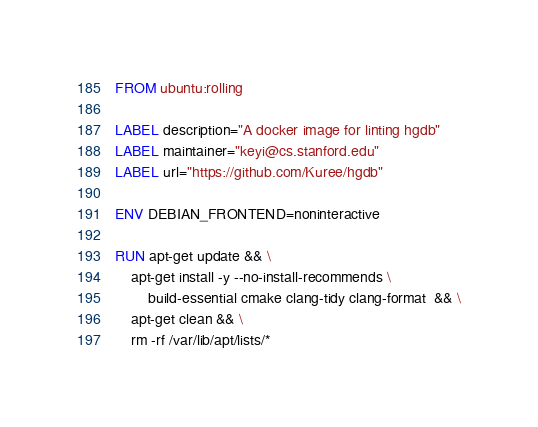Convert code to text. <code><loc_0><loc_0><loc_500><loc_500><_Dockerfile_>FROM ubuntu:rolling

LABEL description="A docker image for linting hgdb"
LABEL maintainer="keyi@cs.stanford.edu"
LABEL url="https://github.com/Kuree/hgdb"

ENV DEBIAN_FRONTEND=noninteractive

RUN apt-get update && \
    apt-get install -y --no-install-recommends \
        build-essential cmake clang-tidy clang-format  && \
    apt-get clean && \
    rm -rf /var/lib/apt/lists/*
</code> 